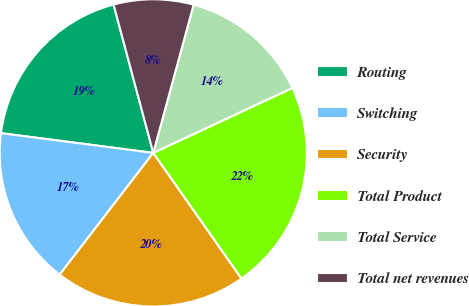Convert chart. <chart><loc_0><loc_0><loc_500><loc_500><pie_chart><fcel>Routing<fcel>Switching<fcel>Security<fcel>Total Product<fcel>Total Service<fcel>Total net revenues<nl><fcel>18.79%<fcel>16.62%<fcel>20.17%<fcel>22.21%<fcel>13.82%<fcel>8.39%<nl></chart> 